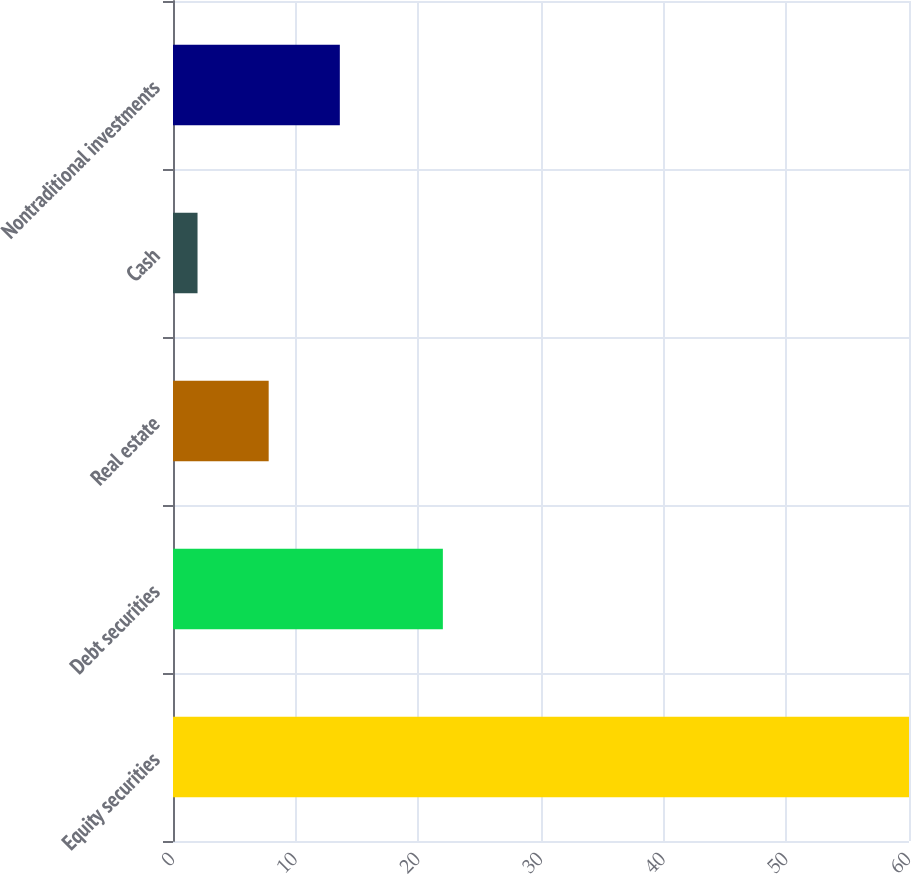<chart> <loc_0><loc_0><loc_500><loc_500><bar_chart><fcel>Equity securities<fcel>Debt securities<fcel>Real estate<fcel>Cash<fcel>Nontraditional investments<nl><fcel>60<fcel>22<fcel>7.8<fcel>2<fcel>13.6<nl></chart> 